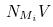<formula> <loc_0><loc_0><loc_500><loc_500>N _ { M _ { i } } V</formula> 